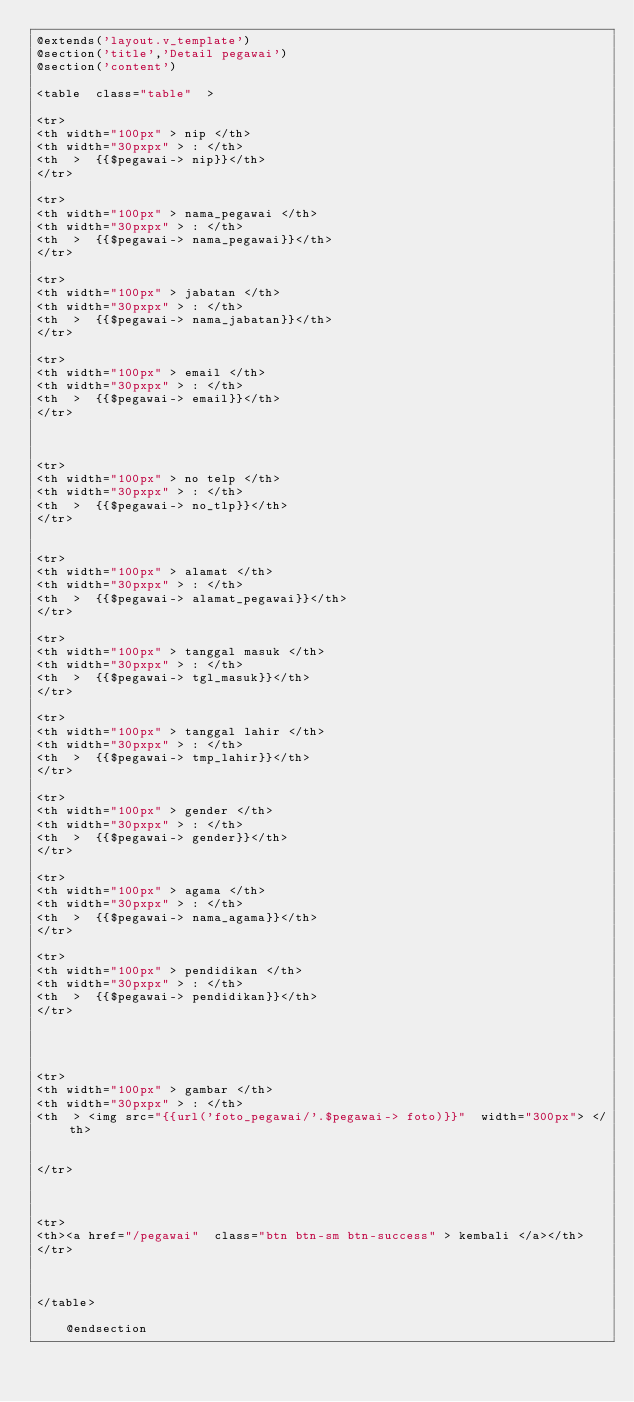Convert code to text. <code><loc_0><loc_0><loc_500><loc_500><_PHP_>@extends('layout.v_template')
@section('title','Detail pegawai')
@section('content')
  
<table  class="table"  >

<tr>
<th width="100px" > nip </th>
<th width="30pxpx" > : </th>
<th  >  {{$pegawai-> nip}}</th>
</tr>

<tr>
<th width="100px" > nama_pegawai </th>
<th width="30pxpx" > : </th>
<th  >  {{$pegawai-> nama_pegawai}}</th>
</tr>

<tr>
<th width="100px" > jabatan </th>
<th width="30pxpx" > : </th>
<th  >  {{$pegawai-> nama_jabatan}}</th>
</tr>

<tr>
<th width="100px" > email </th>
<th width="30pxpx" > : </th>
<th  >  {{$pegawai-> email}}</th>
</tr>



<tr>
<th width="100px" > no telp </th>
<th width="30pxpx" > : </th>
<th  >  {{$pegawai-> no_tlp}}</th>
</tr>


<tr>
<th width="100px" > alamat </th>
<th width="30pxpx" > : </th>
<th  >  {{$pegawai-> alamat_pegawai}}</th>
</tr>

<tr>
<th width="100px" > tanggal masuk </th>
<th width="30pxpx" > : </th>
<th  >  {{$pegawai-> tgl_masuk}}</th>
</tr>

<tr>
<th width="100px" > tanggal lahir </th>
<th width="30pxpx" > : </th>
<th  >  {{$pegawai-> tmp_lahir}}</th>
</tr>

<tr>
<th width="100px" > gender </th>
<th width="30pxpx" > : </th>
<th  >  {{$pegawai-> gender}}</th>
</tr>

<tr>
<th width="100px" > agama </th>
<th width="30pxpx" > : </th>
<th  >  {{$pegawai-> nama_agama}}</th>
</tr>

<tr>
<th width="100px" > pendidikan </th>
<th width="30pxpx" > : </th>
<th  >  {{$pegawai-> pendidikan}}</th>
</tr>




<tr>
<th width="100px" > gambar </th>
<th width="30pxpx" > : </th>
<th  > <img src="{{url('foto_pegawai/'.$pegawai-> foto)}}"  width="300px"> </th>


</tr>



<tr>
<th><a href="/pegawai"  class="btn btn-sm btn-success" > kembali </a></th>
</tr>



</table>

    @endsection</code> 